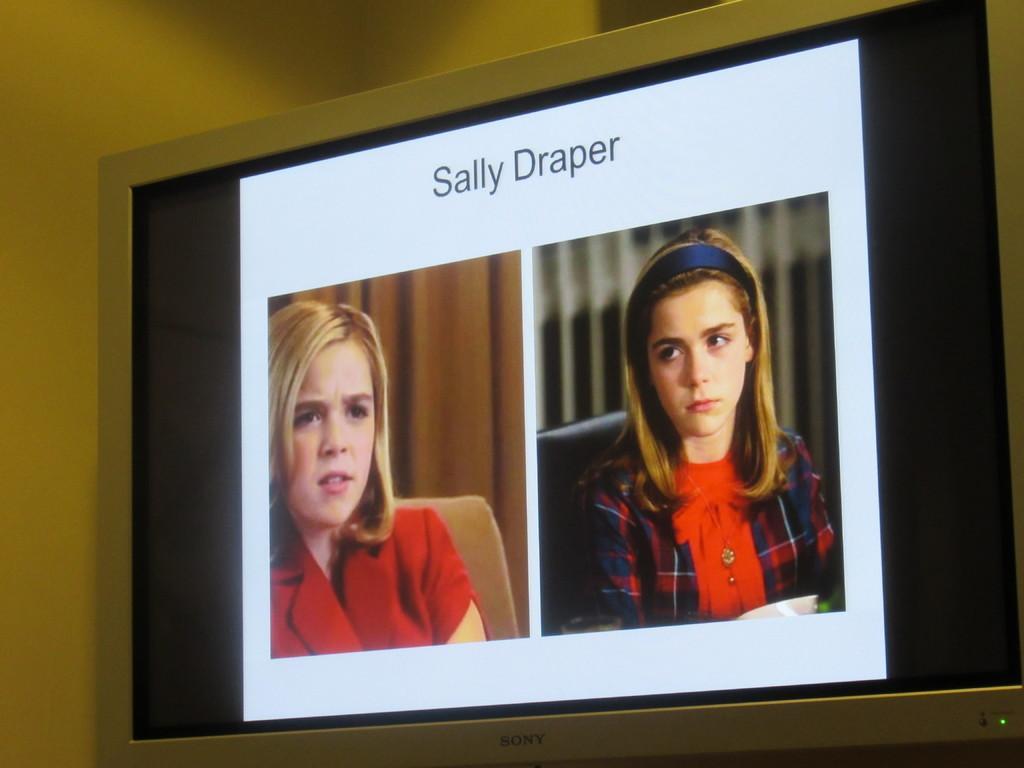In one or two sentences, can you explain what this image depicts? In this image we can see one Sony T. V near to the wall. In this T. V we can see one picture with two girls sitting on the chairs, background there are two curtains, some text in this picture and some objects on the surface. 